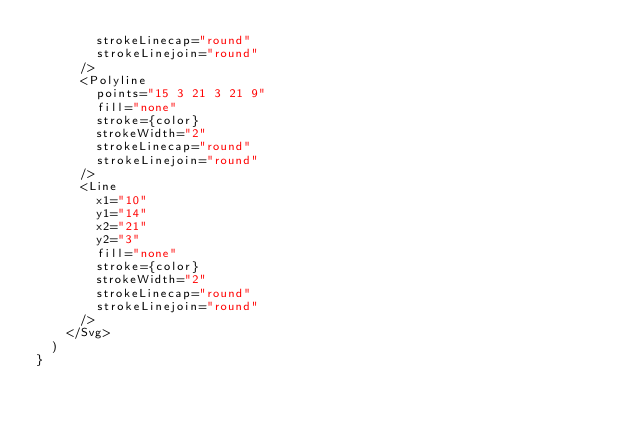Convert code to text. <code><loc_0><loc_0><loc_500><loc_500><_TypeScript_>        strokeLinecap="round"
        strokeLinejoin="round"
      />
      <Polyline
        points="15 3 21 3 21 9"
        fill="none"
        stroke={color}
        strokeWidth="2"
        strokeLinecap="round"
        strokeLinejoin="round"
      />
      <Line
        x1="10"
        y1="14"
        x2="21"
        y2="3"
        fill="none"
        stroke={color}
        strokeWidth="2"
        strokeLinecap="round"
        strokeLinejoin="round"
      />
    </Svg>
  )
}
</code> 